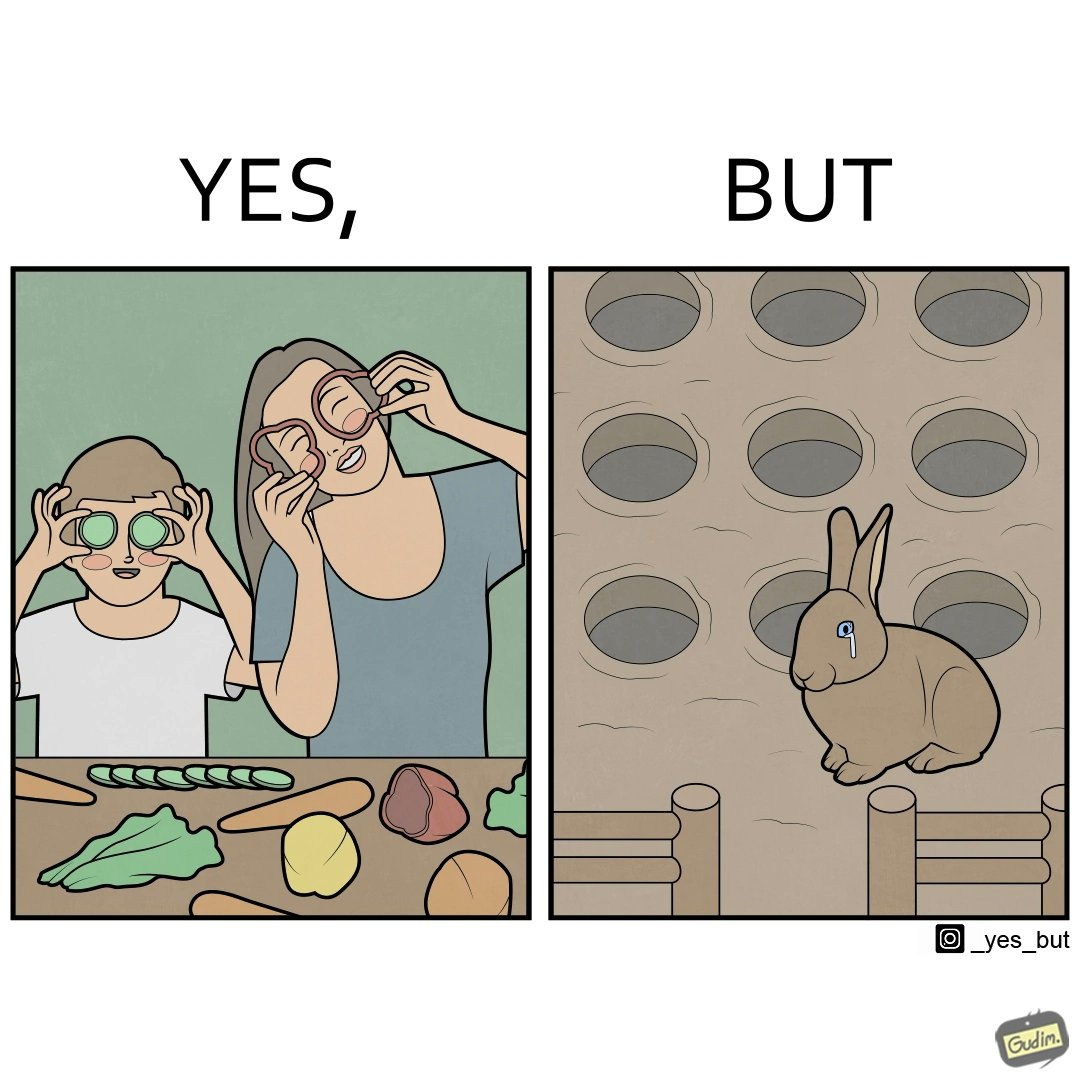What is shown in the left half versus the right half of this image? In the left part of the image: It is a woman and child making funny shapes with vegetables and playing with them In the right part of the image: It is rabbit crying in a ground full of holes 